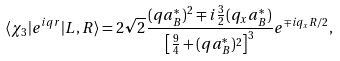Convert formula to latex. <formula><loc_0><loc_0><loc_500><loc_500>\langle \chi _ { 3 } | e ^ { i { q r } } | L , R \rangle = 2 \sqrt { 2 } \frac { ( q a _ { B } ^ { * } ) ^ { 2 } \mp i \frac { 3 } { 2 } ( q _ { x } a _ { B } ^ { * } ) } { \left [ \frac { 9 } { 4 } + ( q a _ { B } ^ { * } ) ^ { 2 } \right ] ^ { 3 } } e ^ { \mp i q _ { x } R / 2 } ,</formula> 